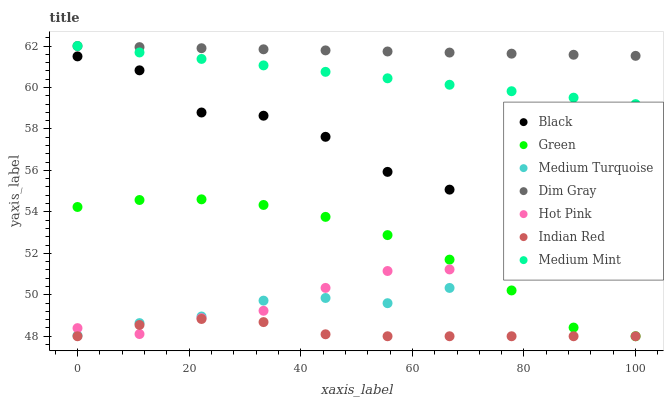Does Indian Red have the minimum area under the curve?
Answer yes or no. Yes. Does Dim Gray have the maximum area under the curve?
Answer yes or no. Yes. Does Medium Turquoise have the minimum area under the curve?
Answer yes or no. No. Does Medium Turquoise have the maximum area under the curve?
Answer yes or no. No. Is Medium Mint the smoothest?
Answer yes or no. Yes. Is Black the roughest?
Answer yes or no. Yes. Is Dim Gray the smoothest?
Answer yes or no. No. Is Dim Gray the roughest?
Answer yes or no. No. Does Green have the lowest value?
Answer yes or no. Yes. Does Medium Turquoise have the lowest value?
Answer yes or no. No. Does Dim Gray have the highest value?
Answer yes or no. Yes. Does Medium Turquoise have the highest value?
Answer yes or no. No. Is Indian Red less than Medium Turquoise?
Answer yes or no. Yes. Is Medium Turquoise greater than Indian Red?
Answer yes or no. Yes. Does Green intersect Hot Pink?
Answer yes or no. Yes. Is Green less than Hot Pink?
Answer yes or no. No. Is Green greater than Hot Pink?
Answer yes or no. No. Does Indian Red intersect Medium Turquoise?
Answer yes or no. No. 